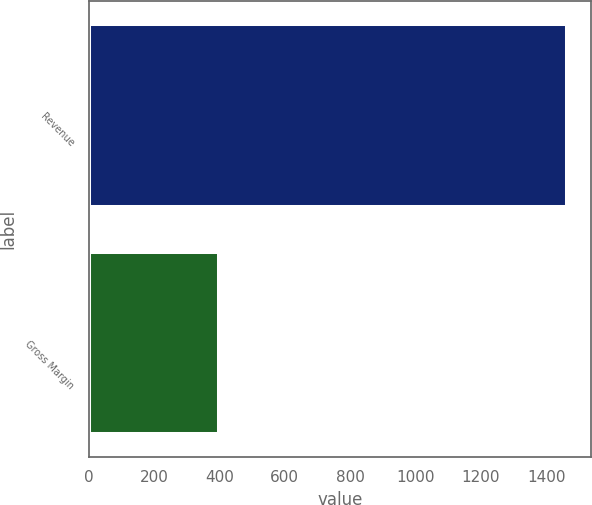Convert chart. <chart><loc_0><loc_0><loc_500><loc_500><bar_chart><fcel>Revenue<fcel>Gross Margin<nl><fcel>1465<fcel>400<nl></chart> 